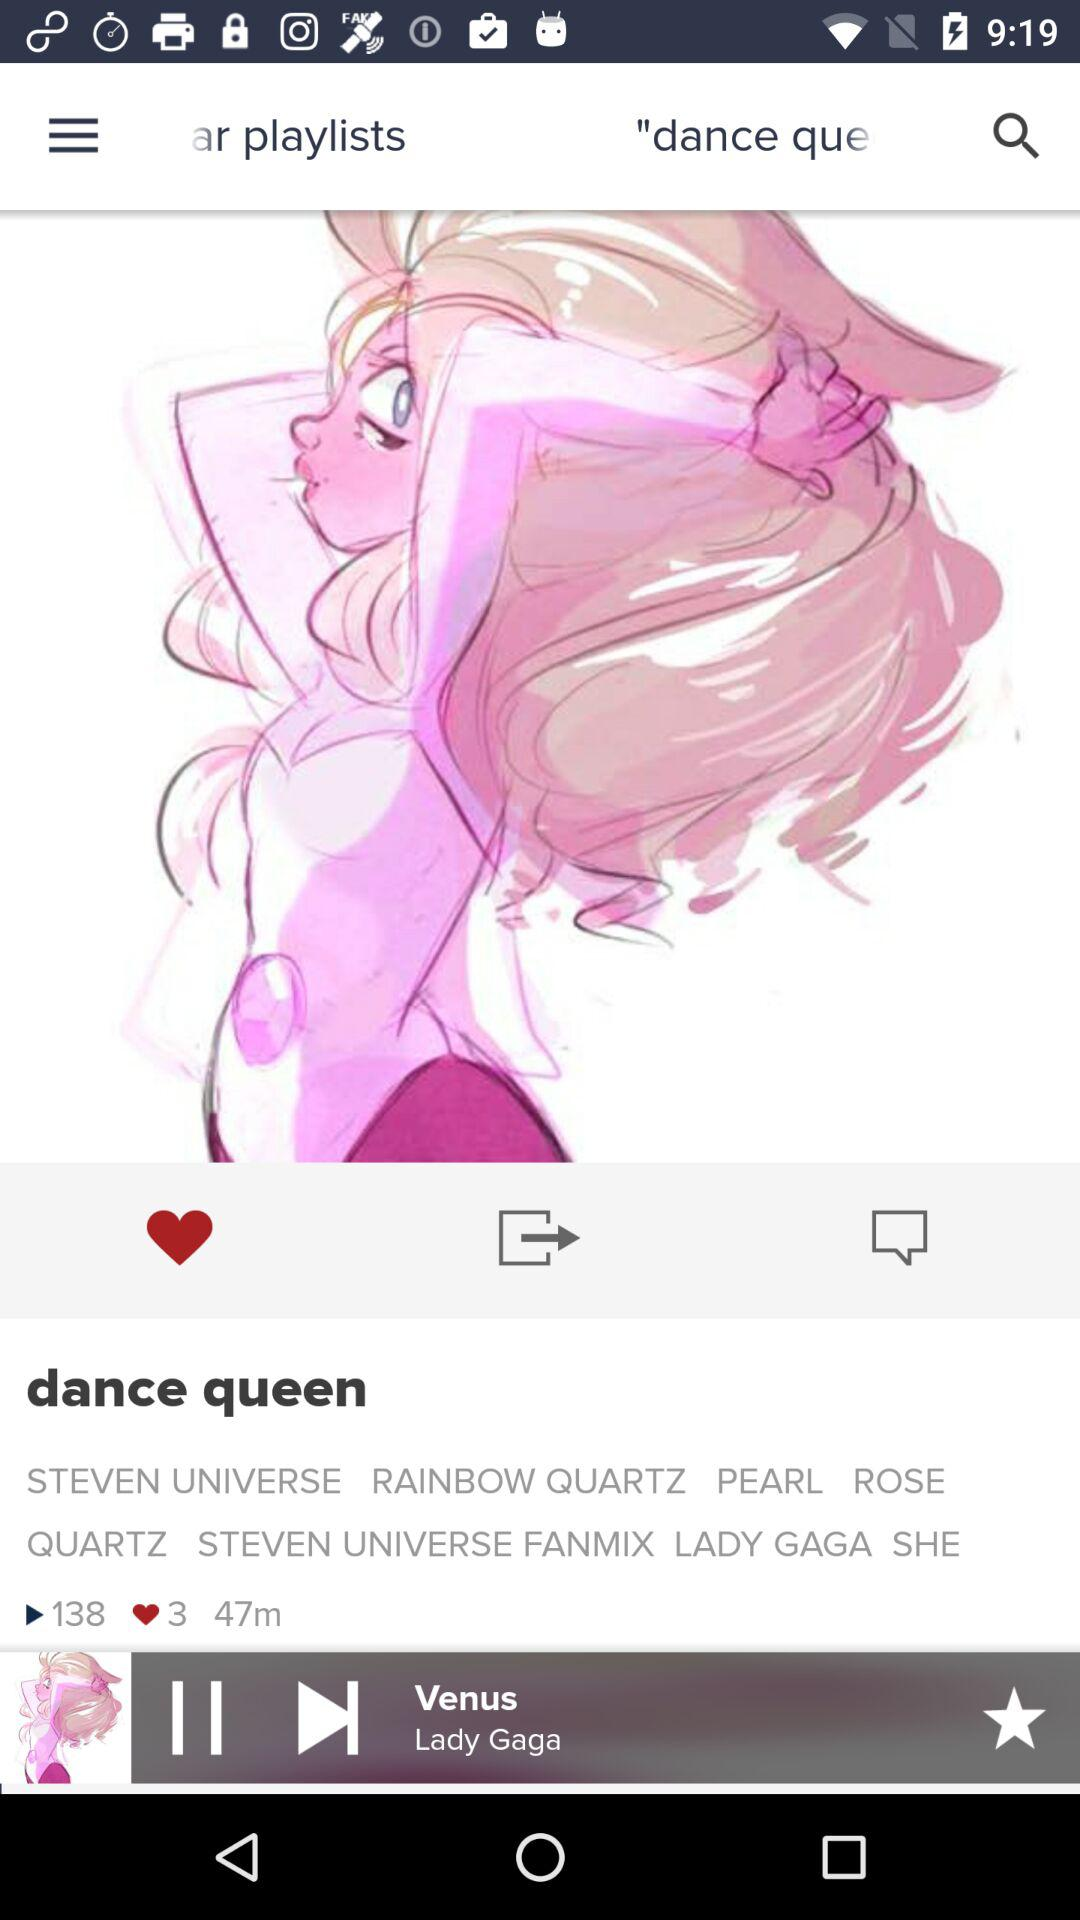How many times has the playlist been played? The playlist has been played 138 times. 